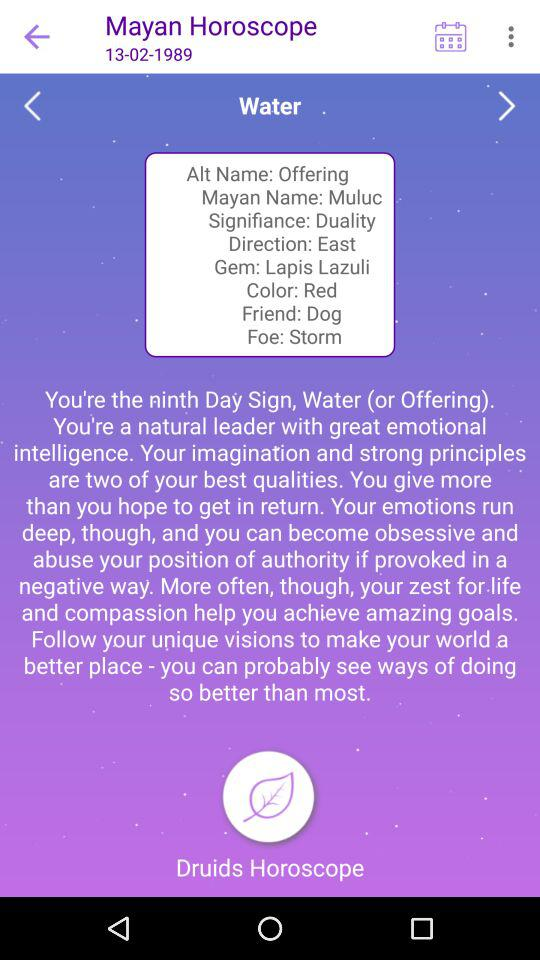What is the "Foe"? The "Foe" is "Storm". 